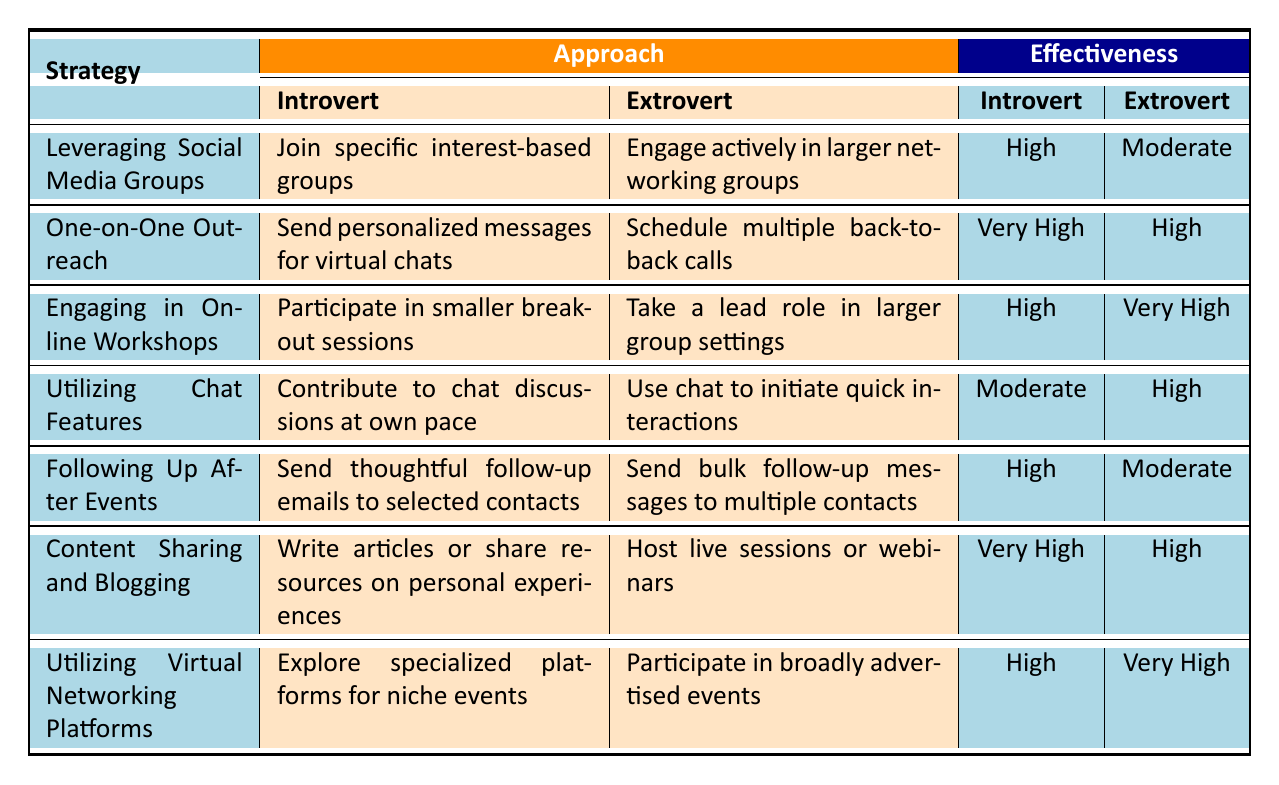What is the effectiveness rating for introverts in "One-on-One Outreach"? The table indicates that the effectiveness rating for introverts in the strategy of "One-on-One Outreach" is "Very High."
Answer: Very High What approach do extroverts take in "Leveraging Social Media Groups"? The table shows that extroverts engage actively in larger networking groups as their approach in "Leveraging Social Media Groups."
Answer: Engage actively in larger networking groups Which strategy has the highest effectiveness for introverts? Comparing the effectiveness ratings for introverts, "One-on-One Outreach" has the highest effectiveness rating of "Very High."
Answer: One-on-One Outreach Do introverts find "Utilizing Chat Features" effective? The effectiveness rating for introverts in "Utilizing Chat Features" is "Moderate," indicating a lower level of effectiveness.
Answer: Yes, it's Moderate Which networking strategy shows the greatest effectiveness difference between introverts and extroverts? Looking at the effectiveness ratings, "Engaging in Online Workshops" has a significant difference, with extroverts rated "Very High" and introverts rated "High," making it the greatest difference.
Answer: Engaging in Online Workshops How do introverts and extroverts differ in their approach to "Content Sharing and Blogging"? Introverts write articles or share resources on personal experiences, while extroverts host live sessions or webinars, showing distinct approaches to the same strategy.
Answer: They differ in their approaches What is the average effectiveness rating for extroverts across all strategies? Totaling the effectiveness ratings for extroverts (Moderate, High, Very High, High, Moderate, High, Very High) and converting them to a numerical scale (Moderate=2, High=3, Very High=4), we get (2+3+4+3+2+3+4)/7 = 3 = High average rating.
Answer: High Is "Following Up After Events" more effective for introverts or extroverts? The table shows that "Following Up After Events" is rated "High" for introverts and "Moderate" for extroverts, indicating it's more effective for introverts.
Answer: More effective for introverts What two approaches do extroverts use for "Utilizing Virtual Networking Platforms"? Extroverts participate in broadly advertised events and maximize visibility and connection, indicating an active engagement with larger audiences.
Answer: They participate in broadly advertised events and maximize visibility Which strategy is least effective for introverts? Among the listed effectiveness ratings, "Utilizing Chat Features" has the lowest effectiveness for introverts with a rating of "Moderate."
Answer: Utilizing Chat Features 